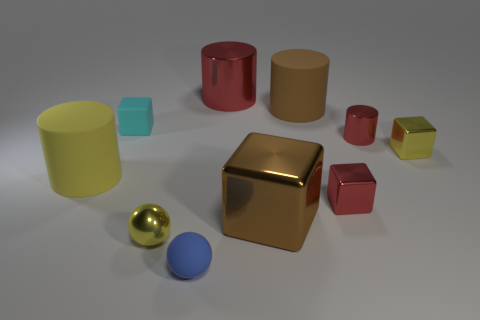What size is the rubber thing that is to the right of the tiny cyan block and behind the blue matte thing?
Give a very brief answer. Large. There is a metallic cylinder that is behind the brown matte thing; is its size the same as the matte block?
Provide a short and direct response. No. What number of cylinders are small green rubber things or yellow rubber objects?
Your answer should be very brief. 1. There is a small cylinder that is the same material as the big brown cube; what is its color?
Your response must be concise. Red. Is the material of the large red object the same as the cube that is to the left of the small blue rubber thing?
Offer a very short reply. No. What number of objects are tiny red metal objects or big brown blocks?
Offer a very short reply. 3. There is a big cylinder that is the same color as the tiny metallic cylinder; what is it made of?
Provide a short and direct response. Metal. Are there any large gray things that have the same shape as the yellow matte thing?
Your answer should be compact. No. How many cyan cubes are on the left side of the blue rubber object?
Keep it short and to the point. 1. There is a tiny yellow object that is in front of the brown object that is in front of the yellow metal cube; what is its material?
Offer a terse response. Metal. 